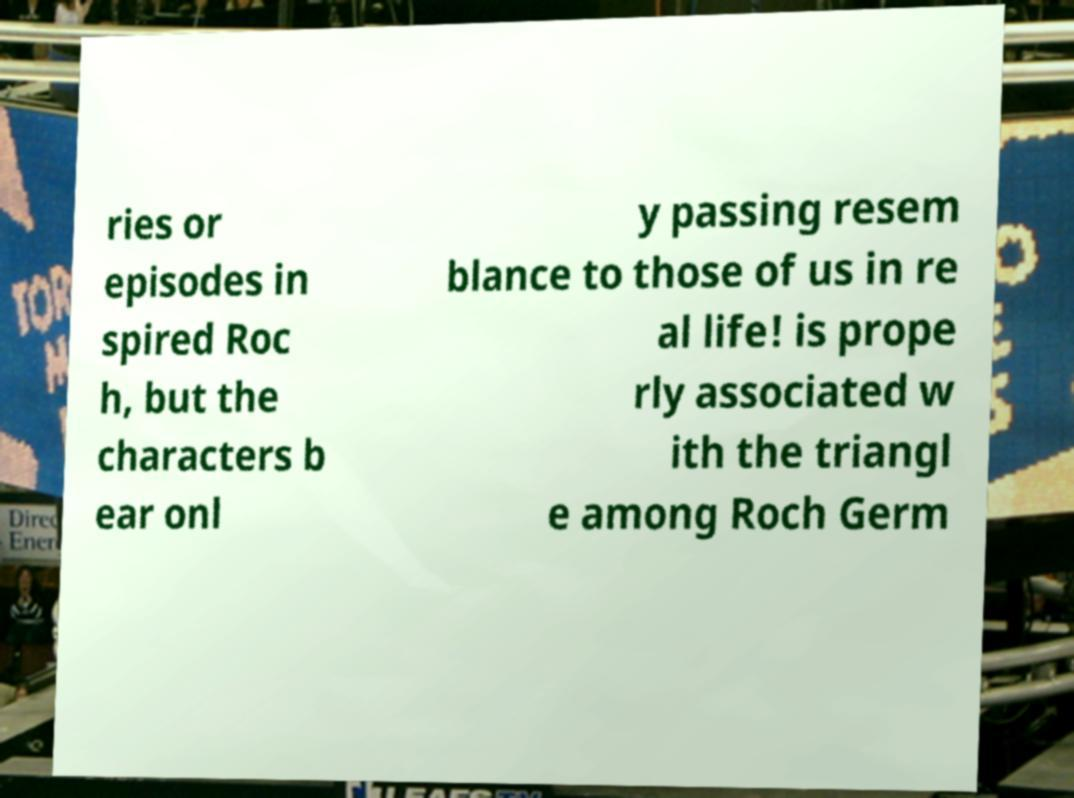Please identify and transcribe the text found in this image. ries or episodes in spired Roc h, but the characters b ear onl y passing resem blance to those of us in re al life! is prope rly associated w ith the triangl e among Roch Germ 